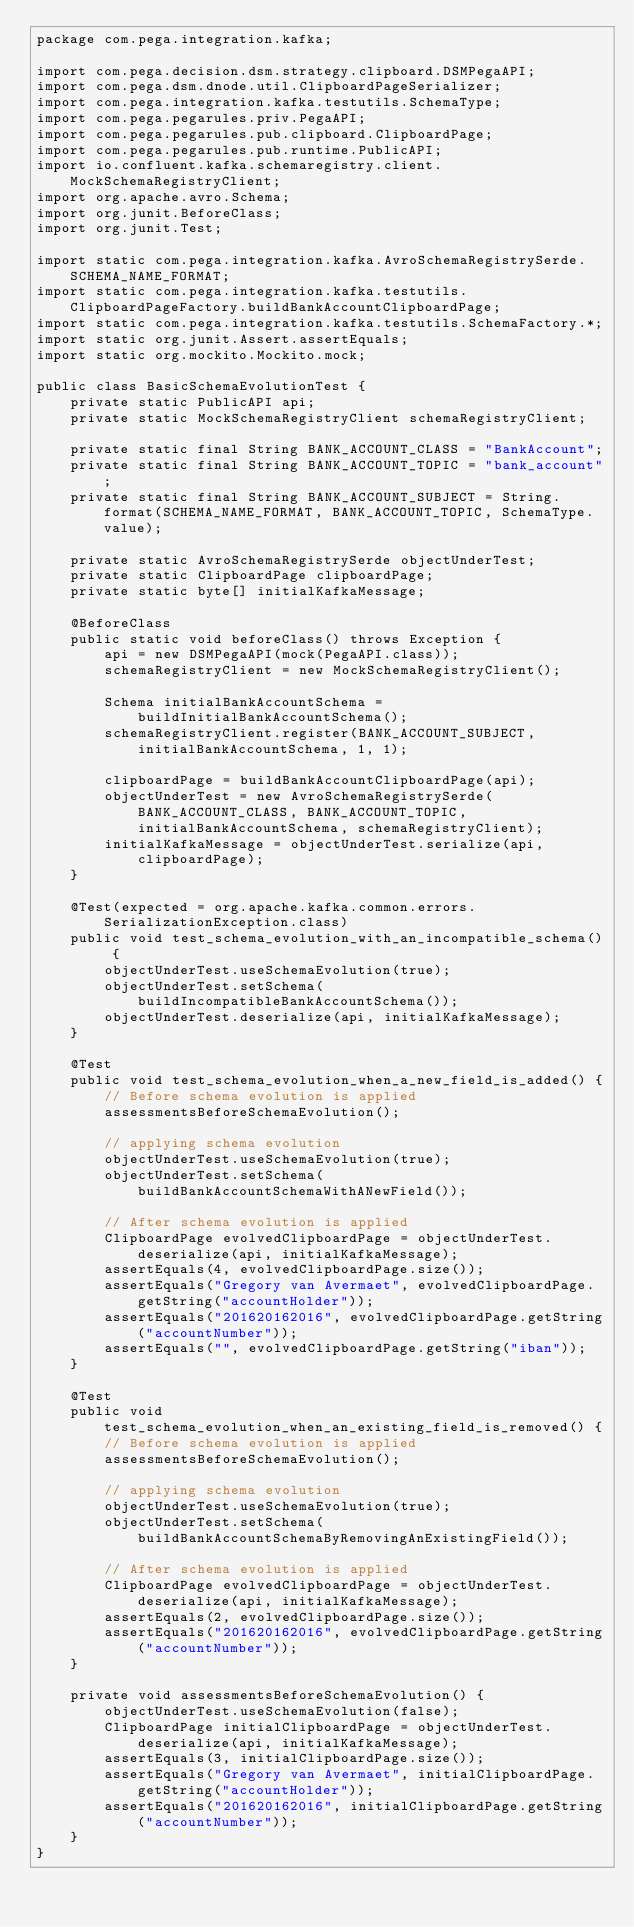Convert code to text. <code><loc_0><loc_0><loc_500><loc_500><_Java_>package com.pega.integration.kafka;

import com.pega.decision.dsm.strategy.clipboard.DSMPegaAPI;
import com.pega.dsm.dnode.util.ClipboardPageSerializer;
import com.pega.integration.kafka.testutils.SchemaType;
import com.pega.pegarules.priv.PegaAPI;
import com.pega.pegarules.pub.clipboard.ClipboardPage;
import com.pega.pegarules.pub.runtime.PublicAPI;
import io.confluent.kafka.schemaregistry.client.MockSchemaRegistryClient;
import org.apache.avro.Schema;
import org.junit.BeforeClass;
import org.junit.Test;

import static com.pega.integration.kafka.AvroSchemaRegistrySerde.SCHEMA_NAME_FORMAT;
import static com.pega.integration.kafka.testutils.ClipboardPageFactory.buildBankAccountClipboardPage;
import static com.pega.integration.kafka.testutils.SchemaFactory.*;
import static org.junit.Assert.assertEquals;
import static org.mockito.Mockito.mock;

public class BasicSchemaEvolutionTest {
    private static PublicAPI api;
    private static MockSchemaRegistryClient schemaRegistryClient;

    private static final String BANK_ACCOUNT_CLASS = "BankAccount";
    private static final String BANK_ACCOUNT_TOPIC = "bank_account";
    private static final String BANK_ACCOUNT_SUBJECT = String.format(SCHEMA_NAME_FORMAT, BANK_ACCOUNT_TOPIC, SchemaType.value);

    private static AvroSchemaRegistrySerde objectUnderTest;
    private static ClipboardPage clipboardPage;
    private static byte[] initialKafkaMessage;

    @BeforeClass
    public static void beforeClass() throws Exception {
        api = new DSMPegaAPI(mock(PegaAPI.class));
        schemaRegistryClient = new MockSchemaRegistryClient();

        Schema initialBankAccountSchema = buildInitialBankAccountSchema();
        schemaRegistryClient.register(BANK_ACCOUNT_SUBJECT, initialBankAccountSchema, 1, 1);

        clipboardPage = buildBankAccountClipboardPage(api);
        objectUnderTest = new AvroSchemaRegistrySerde(BANK_ACCOUNT_CLASS, BANK_ACCOUNT_TOPIC, initialBankAccountSchema, schemaRegistryClient);
        initialKafkaMessage = objectUnderTest.serialize(api, clipboardPage);
    }

    @Test(expected = org.apache.kafka.common.errors.SerializationException.class)
    public void test_schema_evolution_with_an_incompatible_schema() {
        objectUnderTest.useSchemaEvolution(true);
        objectUnderTest.setSchema(buildIncompatibleBankAccountSchema());
        objectUnderTest.deserialize(api, initialKafkaMessage);
    }

    @Test
    public void test_schema_evolution_when_a_new_field_is_added() {
        // Before schema evolution is applied
        assessmentsBeforeSchemaEvolution();

        // applying schema evolution
        objectUnderTest.useSchemaEvolution(true);
        objectUnderTest.setSchema(buildBankAccountSchemaWithANewField());

        // After schema evolution is applied
        ClipboardPage evolvedClipboardPage = objectUnderTest.deserialize(api, initialKafkaMessage);
        assertEquals(4, evolvedClipboardPage.size());
        assertEquals("Gregory van Avermaet", evolvedClipboardPage.getString("accountHolder"));
        assertEquals("201620162016", evolvedClipboardPage.getString("accountNumber"));
        assertEquals("", evolvedClipboardPage.getString("iban"));
    }

    @Test
    public void test_schema_evolution_when_an_existing_field_is_removed() {
        // Before schema evolution is applied
        assessmentsBeforeSchemaEvolution();

        // applying schema evolution
        objectUnderTest.useSchemaEvolution(true);
        objectUnderTest.setSchema(buildBankAccountSchemaByRemovingAnExistingField());

        // After schema evolution is applied
        ClipboardPage evolvedClipboardPage = objectUnderTest.deserialize(api, initialKafkaMessage);
        assertEquals(2, evolvedClipboardPage.size());
        assertEquals("201620162016", evolvedClipboardPage.getString("accountNumber"));
    }

    private void assessmentsBeforeSchemaEvolution() {
        objectUnderTest.useSchemaEvolution(false);
        ClipboardPage initialClipboardPage = objectUnderTest.deserialize(api, initialKafkaMessage);
        assertEquals(3, initialClipboardPage.size());
        assertEquals("Gregory van Avermaet", initialClipboardPage.getString("accountHolder"));
        assertEquals("201620162016", initialClipboardPage.getString("accountNumber"));
    }
}</code> 